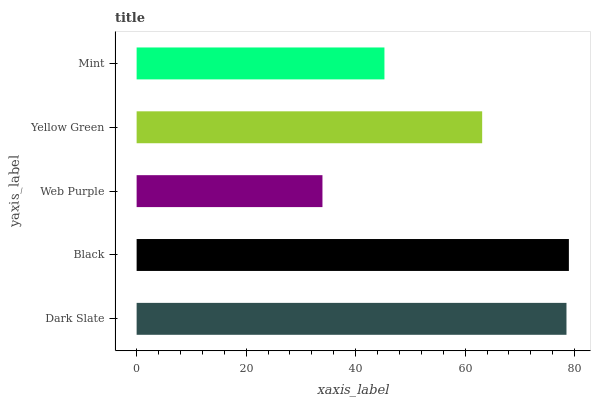Is Web Purple the minimum?
Answer yes or no. Yes. Is Black the maximum?
Answer yes or no. Yes. Is Black the minimum?
Answer yes or no. No. Is Web Purple the maximum?
Answer yes or no. No. Is Black greater than Web Purple?
Answer yes or no. Yes. Is Web Purple less than Black?
Answer yes or no. Yes. Is Web Purple greater than Black?
Answer yes or no. No. Is Black less than Web Purple?
Answer yes or no. No. Is Yellow Green the high median?
Answer yes or no. Yes. Is Yellow Green the low median?
Answer yes or no. Yes. Is Web Purple the high median?
Answer yes or no. No. Is Web Purple the low median?
Answer yes or no. No. 